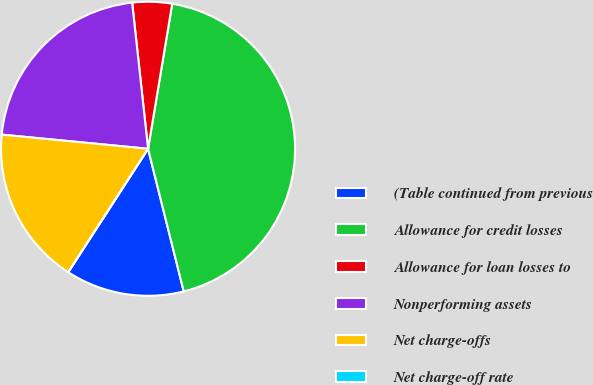<chart> <loc_0><loc_0><loc_500><loc_500><pie_chart><fcel>(Table continued from previous<fcel>Allowance for credit losses<fcel>Allowance for loan losses to<fcel>Nonperforming assets<fcel>Net charge-offs<fcel>Net charge-off rate<nl><fcel>13.04%<fcel>43.47%<fcel>4.35%<fcel>21.74%<fcel>17.39%<fcel>0.0%<nl></chart> 